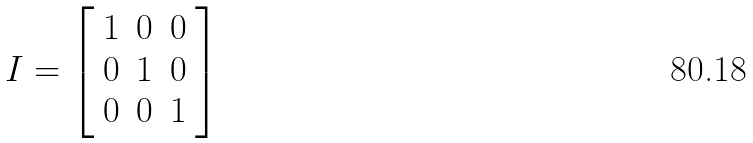<formula> <loc_0><loc_0><loc_500><loc_500>I = \left [ \begin{array} { l l l } 1 & 0 & 0 \\ 0 & 1 & 0 \\ 0 & 0 & 1 \end{array} \right ]</formula> 